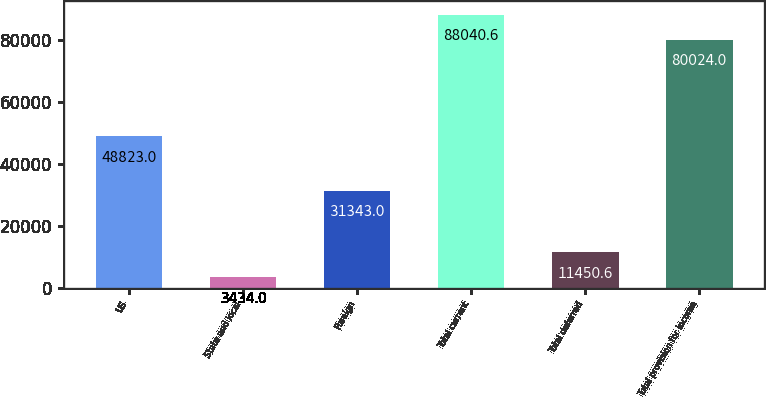<chart> <loc_0><loc_0><loc_500><loc_500><bar_chart><fcel>US<fcel>State and local<fcel>Foreign<fcel>Total current<fcel>Total deferred<fcel>Total provision for income<nl><fcel>48823<fcel>3434<fcel>31343<fcel>88040.6<fcel>11450.6<fcel>80024<nl></chart> 